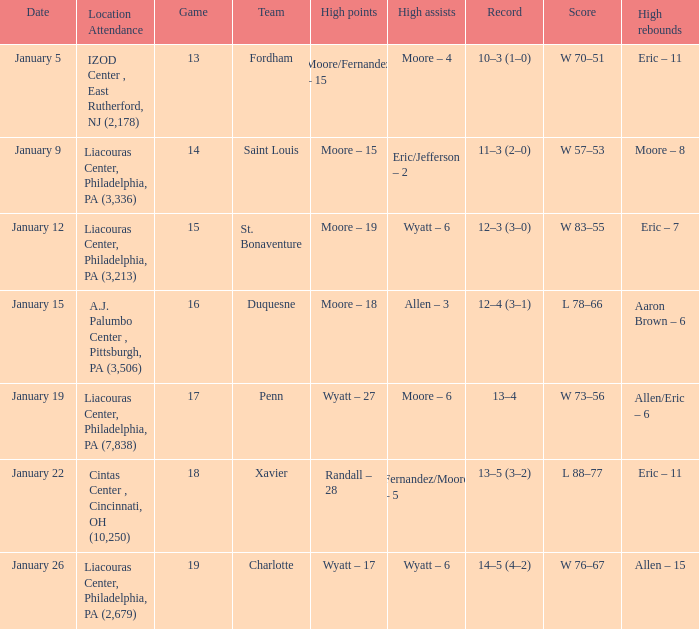Who had the most assists and how many did they have on January 5? Moore – 4. 